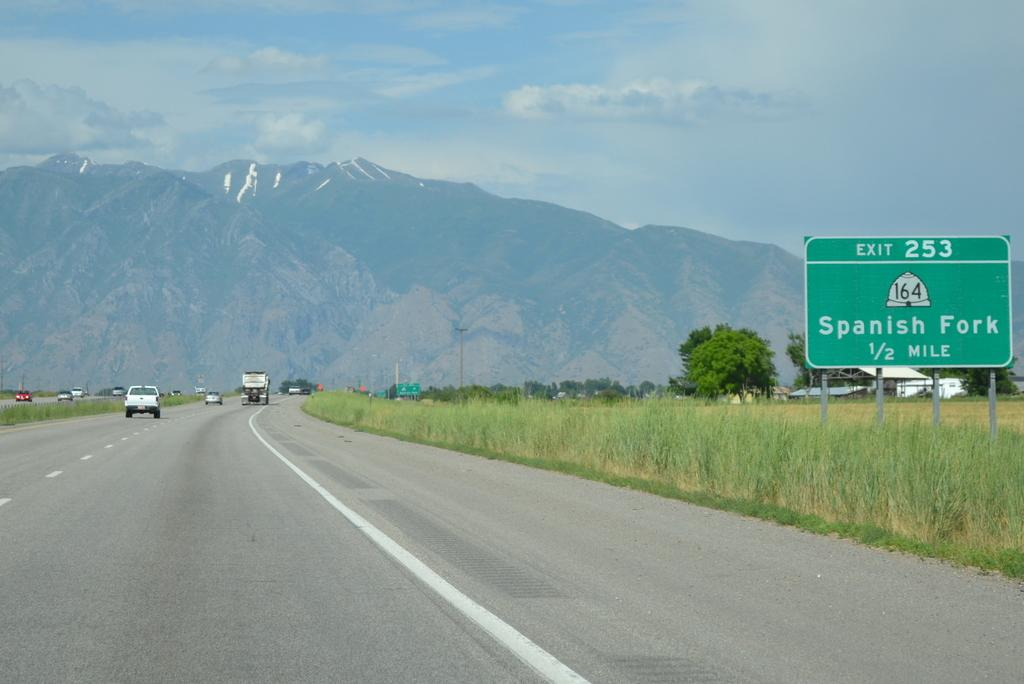Provide a one-sentence caption for the provided image. A freeway with cars driving down it and there is a sign to the side that reads Exit 253 Spanish Fork 1/2 mile. 